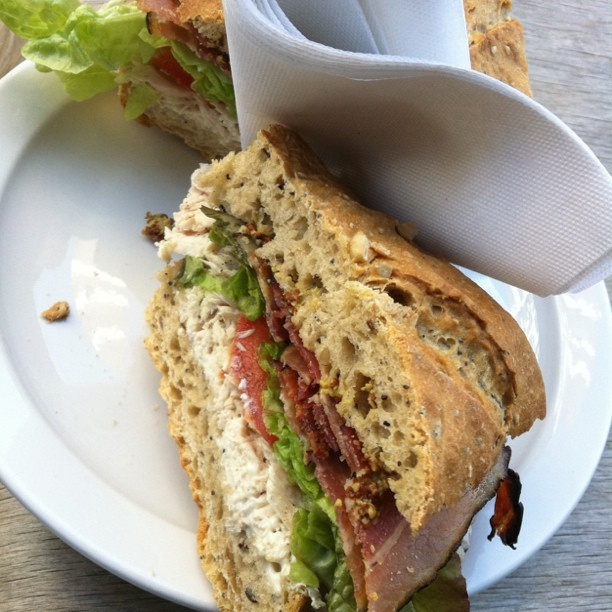Describe the objects in this image and their specific colors. I can see sandwich in olive, tan, and gray tones, sandwich in olive and maroon tones, and dining table in olive, darkgray, lightgray, and gray tones in this image. 